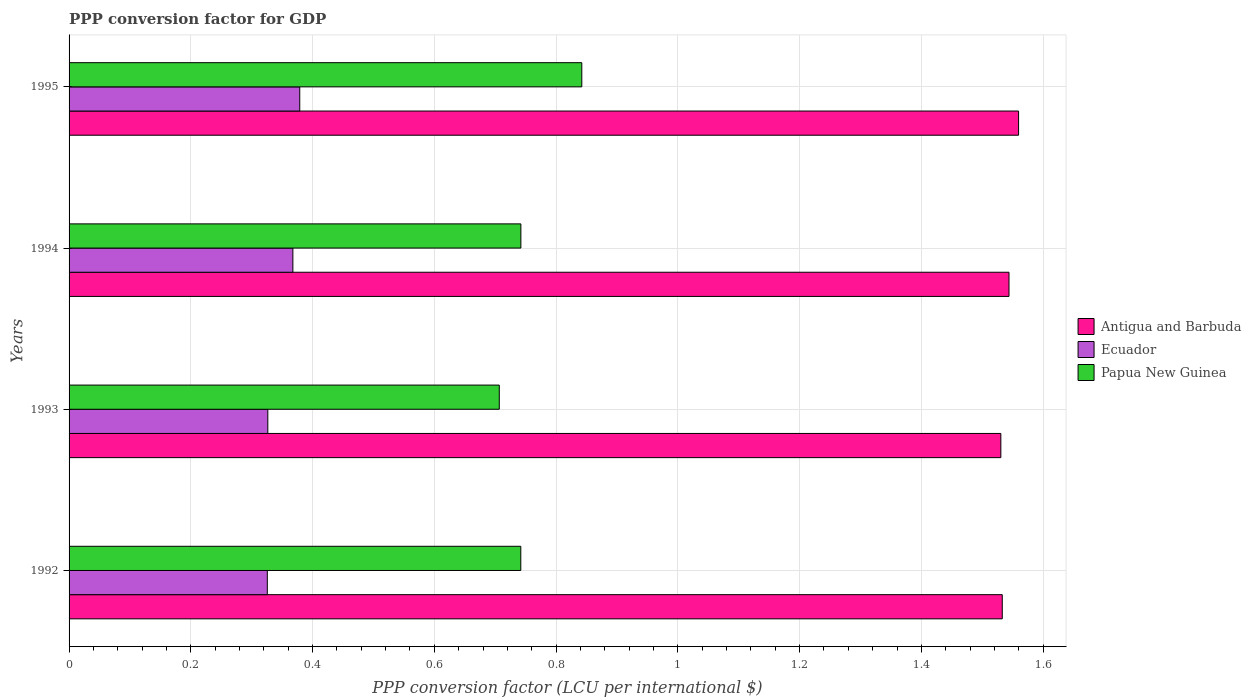Are the number of bars per tick equal to the number of legend labels?
Offer a terse response. Yes. How many bars are there on the 3rd tick from the top?
Keep it short and to the point. 3. What is the label of the 2nd group of bars from the top?
Provide a short and direct response. 1994. In how many cases, is the number of bars for a given year not equal to the number of legend labels?
Your answer should be very brief. 0. What is the PPP conversion factor for GDP in Papua New Guinea in 1994?
Offer a very short reply. 0.74. Across all years, what is the maximum PPP conversion factor for GDP in Ecuador?
Make the answer very short. 0.38. Across all years, what is the minimum PPP conversion factor for GDP in Ecuador?
Offer a very short reply. 0.33. In which year was the PPP conversion factor for GDP in Ecuador minimum?
Your answer should be compact. 1992. What is the total PPP conversion factor for GDP in Papua New Guinea in the graph?
Offer a very short reply. 3.03. What is the difference between the PPP conversion factor for GDP in Ecuador in 1992 and that in 1993?
Offer a very short reply. -0. What is the difference between the PPP conversion factor for GDP in Ecuador in 1993 and the PPP conversion factor for GDP in Papua New Guinea in 1992?
Your answer should be compact. -0.42. What is the average PPP conversion factor for GDP in Ecuador per year?
Offer a very short reply. 0.35. In the year 1994, what is the difference between the PPP conversion factor for GDP in Antigua and Barbuda and PPP conversion factor for GDP in Papua New Guinea?
Your answer should be very brief. 0.8. What is the ratio of the PPP conversion factor for GDP in Ecuador in 1992 to that in 1994?
Your answer should be very brief. 0.89. What is the difference between the highest and the second highest PPP conversion factor for GDP in Antigua and Barbuda?
Your response must be concise. 0.02. What is the difference between the highest and the lowest PPP conversion factor for GDP in Antigua and Barbuda?
Offer a very short reply. 0.03. In how many years, is the PPP conversion factor for GDP in Antigua and Barbuda greater than the average PPP conversion factor for GDP in Antigua and Barbuda taken over all years?
Your answer should be compact. 2. What does the 3rd bar from the top in 1995 represents?
Your answer should be compact. Antigua and Barbuda. What does the 2nd bar from the bottom in 1994 represents?
Provide a succinct answer. Ecuador. How many bars are there?
Your answer should be compact. 12. How many years are there in the graph?
Your answer should be very brief. 4. Are the values on the major ticks of X-axis written in scientific E-notation?
Provide a short and direct response. No. Where does the legend appear in the graph?
Offer a very short reply. Center right. How are the legend labels stacked?
Provide a short and direct response. Vertical. What is the title of the graph?
Your response must be concise. PPP conversion factor for GDP. Does "Portugal" appear as one of the legend labels in the graph?
Offer a very short reply. No. What is the label or title of the X-axis?
Your answer should be compact. PPP conversion factor (LCU per international $). What is the label or title of the Y-axis?
Ensure brevity in your answer.  Years. What is the PPP conversion factor (LCU per international $) in Antigua and Barbuda in 1992?
Your response must be concise. 1.53. What is the PPP conversion factor (LCU per international $) of Ecuador in 1992?
Ensure brevity in your answer.  0.33. What is the PPP conversion factor (LCU per international $) in Papua New Guinea in 1992?
Make the answer very short. 0.74. What is the PPP conversion factor (LCU per international $) of Antigua and Barbuda in 1993?
Your response must be concise. 1.53. What is the PPP conversion factor (LCU per international $) in Ecuador in 1993?
Your response must be concise. 0.33. What is the PPP conversion factor (LCU per international $) of Papua New Guinea in 1993?
Provide a short and direct response. 0.71. What is the PPP conversion factor (LCU per international $) in Antigua and Barbuda in 1994?
Keep it short and to the point. 1.54. What is the PPP conversion factor (LCU per international $) of Ecuador in 1994?
Ensure brevity in your answer.  0.37. What is the PPP conversion factor (LCU per international $) of Papua New Guinea in 1994?
Your answer should be compact. 0.74. What is the PPP conversion factor (LCU per international $) in Antigua and Barbuda in 1995?
Offer a terse response. 1.56. What is the PPP conversion factor (LCU per international $) of Ecuador in 1995?
Offer a very short reply. 0.38. What is the PPP conversion factor (LCU per international $) of Papua New Guinea in 1995?
Make the answer very short. 0.84. Across all years, what is the maximum PPP conversion factor (LCU per international $) in Antigua and Barbuda?
Offer a terse response. 1.56. Across all years, what is the maximum PPP conversion factor (LCU per international $) of Ecuador?
Provide a short and direct response. 0.38. Across all years, what is the maximum PPP conversion factor (LCU per international $) in Papua New Guinea?
Keep it short and to the point. 0.84. Across all years, what is the minimum PPP conversion factor (LCU per international $) in Antigua and Barbuda?
Your answer should be compact. 1.53. Across all years, what is the minimum PPP conversion factor (LCU per international $) of Ecuador?
Your answer should be very brief. 0.33. Across all years, what is the minimum PPP conversion factor (LCU per international $) of Papua New Guinea?
Give a very brief answer. 0.71. What is the total PPP conversion factor (LCU per international $) of Antigua and Barbuda in the graph?
Offer a terse response. 6.17. What is the total PPP conversion factor (LCU per international $) in Ecuador in the graph?
Keep it short and to the point. 1.4. What is the total PPP conversion factor (LCU per international $) of Papua New Guinea in the graph?
Ensure brevity in your answer.  3.03. What is the difference between the PPP conversion factor (LCU per international $) in Antigua and Barbuda in 1992 and that in 1993?
Offer a terse response. 0. What is the difference between the PPP conversion factor (LCU per international $) in Ecuador in 1992 and that in 1993?
Offer a terse response. -0. What is the difference between the PPP conversion factor (LCU per international $) of Papua New Guinea in 1992 and that in 1993?
Provide a short and direct response. 0.04. What is the difference between the PPP conversion factor (LCU per international $) of Antigua and Barbuda in 1992 and that in 1994?
Your answer should be compact. -0.01. What is the difference between the PPP conversion factor (LCU per international $) of Ecuador in 1992 and that in 1994?
Ensure brevity in your answer.  -0.04. What is the difference between the PPP conversion factor (LCU per international $) of Papua New Guinea in 1992 and that in 1994?
Provide a succinct answer. -0. What is the difference between the PPP conversion factor (LCU per international $) in Antigua and Barbuda in 1992 and that in 1995?
Offer a very short reply. -0.03. What is the difference between the PPP conversion factor (LCU per international $) of Ecuador in 1992 and that in 1995?
Offer a very short reply. -0.05. What is the difference between the PPP conversion factor (LCU per international $) of Papua New Guinea in 1992 and that in 1995?
Offer a terse response. -0.1. What is the difference between the PPP conversion factor (LCU per international $) in Antigua and Barbuda in 1993 and that in 1994?
Your answer should be very brief. -0.01. What is the difference between the PPP conversion factor (LCU per international $) in Ecuador in 1993 and that in 1994?
Your answer should be very brief. -0.04. What is the difference between the PPP conversion factor (LCU per international $) of Papua New Guinea in 1993 and that in 1994?
Your answer should be very brief. -0.04. What is the difference between the PPP conversion factor (LCU per international $) in Antigua and Barbuda in 1993 and that in 1995?
Keep it short and to the point. -0.03. What is the difference between the PPP conversion factor (LCU per international $) in Ecuador in 1993 and that in 1995?
Make the answer very short. -0.05. What is the difference between the PPP conversion factor (LCU per international $) in Papua New Guinea in 1993 and that in 1995?
Keep it short and to the point. -0.14. What is the difference between the PPP conversion factor (LCU per international $) in Antigua and Barbuda in 1994 and that in 1995?
Provide a succinct answer. -0.02. What is the difference between the PPP conversion factor (LCU per international $) of Ecuador in 1994 and that in 1995?
Your answer should be compact. -0.01. What is the difference between the PPP conversion factor (LCU per international $) of Papua New Guinea in 1994 and that in 1995?
Offer a terse response. -0.1. What is the difference between the PPP conversion factor (LCU per international $) of Antigua and Barbuda in 1992 and the PPP conversion factor (LCU per international $) of Ecuador in 1993?
Ensure brevity in your answer.  1.21. What is the difference between the PPP conversion factor (LCU per international $) of Antigua and Barbuda in 1992 and the PPP conversion factor (LCU per international $) of Papua New Guinea in 1993?
Give a very brief answer. 0.83. What is the difference between the PPP conversion factor (LCU per international $) in Ecuador in 1992 and the PPP conversion factor (LCU per international $) in Papua New Guinea in 1993?
Keep it short and to the point. -0.38. What is the difference between the PPP conversion factor (LCU per international $) of Antigua and Barbuda in 1992 and the PPP conversion factor (LCU per international $) of Ecuador in 1994?
Offer a terse response. 1.17. What is the difference between the PPP conversion factor (LCU per international $) of Antigua and Barbuda in 1992 and the PPP conversion factor (LCU per international $) of Papua New Guinea in 1994?
Your answer should be compact. 0.79. What is the difference between the PPP conversion factor (LCU per international $) in Ecuador in 1992 and the PPP conversion factor (LCU per international $) in Papua New Guinea in 1994?
Your answer should be very brief. -0.42. What is the difference between the PPP conversion factor (LCU per international $) in Antigua and Barbuda in 1992 and the PPP conversion factor (LCU per international $) in Ecuador in 1995?
Offer a terse response. 1.15. What is the difference between the PPP conversion factor (LCU per international $) of Antigua and Barbuda in 1992 and the PPP conversion factor (LCU per international $) of Papua New Guinea in 1995?
Ensure brevity in your answer.  0.69. What is the difference between the PPP conversion factor (LCU per international $) of Ecuador in 1992 and the PPP conversion factor (LCU per international $) of Papua New Guinea in 1995?
Your answer should be compact. -0.52. What is the difference between the PPP conversion factor (LCU per international $) of Antigua and Barbuda in 1993 and the PPP conversion factor (LCU per international $) of Ecuador in 1994?
Offer a very short reply. 1.16. What is the difference between the PPP conversion factor (LCU per international $) in Antigua and Barbuda in 1993 and the PPP conversion factor (LCU per international $) in Papua New Guinea in 1994?
Your answer should be very brief. 0.79. What is the difference between the PPP conversion factor (LCU per international $) in Ecuador in 1993 and the PPP conversion factor (LCU per international $) in Papua New Guinea in 1994?
Your answer should be compact. -0.42. What is the difference between the PPP conversion factor (LCU per international $) in Antigua and Barbuda in 1993 and the PPP conversion factor (LCU per international $) in Ecuador in 1995?
Provide a succinct answer. 1.15. What is the difference between the PPP conversion factor (LCU per international $) of Antigua and Barbuda in 1993 and the PPP conversion factor (LCU per international $) of Papua New Guinea in 1995?
Make the answer very short. 0.69. What is the difference between the PPP conversion factor (LCU per international $) in Ecuador in 1993 and the PPP conversion factor (LCU per international $) in Papua New Guinea in 1995?
Offer a terse response. -0.52. What is the difference between the PPP conversion factor (LCU per international $) of Antigua and Barbuda in 1994 and the PPP conversion factor (LCU per international $) of Ecuador in 1995?
Provide a succinct answer. 1.17. What is the difference between the PPP conversion factor (LCU per international $) of Antigua and Barbuda in 1994 and the PPP conversion factor (LCU per international $) of Papua New Guinea in 1995?
Make the answer very short. 0.7. What is the difference between the PPP conversion factor (LCU per international $) in Ecuador in 1994 and the PPP conversion factor (LCU per international $) in Papua New Guinea in 1995?
Offer a very short reply. -0.47. What is the average PPP conversion factor (LCU per international $) of Antigua and Barbuda per year?
Ensure brevity in your answer.  1.54. What is the average PPP conversion factor (LCU per international $) of Ecuador per year?
Your response must be concise. 0.35. What is the average PPP conversion factor (LCU per international $) of Papua New Guinea per year?
Offer a very short reply. 0.76. In the year 1992, what is the difference between the PPP conversion factor (LCU per international $) of Antigua and Barbuda and PPP conversion factor (LCU per international $) of Ecuador?
Your answer should be compact. 1.21. In the year 1992, what is the difference between the PPP conversion factor (LCU per international $) of Antigua and Barbuda and PPP conversion factor (LCU per international $) of Papua New Guinea?
Make the answer very short. 0.79. In the year 1992, what is the difference between the PPP conversion factor (LCU per international $) of Ecuador and PPP conversion factor (LCU per international $) of Papua New Guinea?
Ensure brevity in your answer.  -0.42. In the year 1993, what is the difference between the PPP conversion factor (LCU per international $) in Antigua and Barbuda and PPP conversion factor (LCU per international $) in Ecuador?
Provide a succinct answer. 1.2. In the year 1993, what is the difference between the PPP conversion factor (LCU per international $) in Antigua and Barbuda and PPP conversion factor (LCU per international $) in Papua New Guinea?
Offer a terse response. 0.82. In the year 1993, what is the difference between the PPP conversion factor (LCU per international $) of Ecuador and PPP conversion factor (LCU per international $) of Papua New Guinea?
Your answer should be compact. -0.38. In the year 1994, what is the difference between the PPP conversion factor (LCU per international $) in Antigua and Barbuda and PPP conversion factor (LCU per international $) in Ecuador?
Your answer should be very brief. 1.18. In the year 1994, what is the difference between the PPP conversion factor (LCU per international $) of Antigua and Barbuda and PPP conversion factor (LCU per international $) of Papua New Guinea?
Your answer should be very brief. 0.8. In the year 1994, what is the difference between the PPP conversion factor (LCU per international $) in Ecuador and PPP conversion factor (LCU per international $) in Papua New Guinea?
Provide a short and direct response. -0.37. In the year 1995, what is the difference between the PPP conversion factor (LCU per international $) of Antigua and Barbuda and PPP conversion factor (LCU per international $) of Ecuador?
Provide a short and direct response. 1.18. In the year 1995, what is the difference between the PPP conversion factor (LCU per international $) in Antigua and Barbuda and PPP conversion factor (LCU per international $) in Papua New Guinea?
Ensure brevity in your answer.  0.72. In the year 1995, what is the difference between the PPP conversion factor (LCU per international $) of Ecuador and PPP conversion factor (LCU per international $) of Papua New Guinea?
Give a very brief answer. -0.46. What is the ratio of the PPP conversion factor (LCU per international $) of Antigua and Barbuda in 1992 to that in 1993?
Offer a very short reply. 1. What is the ratio of the PPP conversion factor (LCU per international $) of Ecuador in 1992 to that in 1993?
Ensure brevity in your answer.  1. What is the ratio of the PPP conversion factor (LCU per international $) of Papua New Guinea in 1992 to that in 1993?
Keep it short and to the point. 1.05. What is the ratio of the PPP conversion factor (LCU per international $) in Ecuador in 1992 to that in 1994?
Give a very brief answer. 0.89. What is the ratio of the PPP conversion factor (LCU per international $) in Antigua and Barbuda in 1992 to that in 1995?
Ensure brevity in your answer.  0.98. What is the ratio of the PPP conversion factor (LCU per international $) of Ecuador in 1992 to that in 1995?
Offer a terse response. 0.86. What is the ratio of the PPP conversion factor (LCU per international $) in Papua New Guinea in 1992 to that in 1995?
Provide a succinct answer. 0.88. What is the ratio of the PPP conversion factor (LCU per international $) of Antigua and Barbuda in 1993 to that in 1994?
Make the answer very short. 0.99. What is the ratio of the PPP conversion factor (LCU per international $) of Ecuador in 1993 to that in 1994?
Keep it short and to the point. 0.89. What is the ratio of the PPP conversion factor (LCU per international $) of Papua New Guinea in 1993 to that in 1994?
Ensure brevity in your answer.  0.95. What is the ratio of the PPP conversion factor (LCU per international $) in Antigua and Barbuda in 1993 to that in 1995?
Your answer should be compact. 0.98. What is the ratio of the PPP conversion factor (LCU per international $) in Ecuador in 1993 to that in 1995?
Your answer should be very brief. 0.86. What is the ratio of the PPP conversion factor (LCU per international $) in Papua New Guinea in 1993 to that in 1995?
Provide a succinct answer. 0.84. What is the ratio of the PPP conversion factor (LCU per international $) of Ecuador in 1994 to that in 1995?
Your response must be concise. 0.97. What is the ratio of the PPP conversion factor (LCU per international $) of Papua New Guinea in 1994 to that in 1995?
Your answer should be very brief. 0.88. What is the difference between the highest and the second highest PPP conversion factor (LCU per international $) in Antigua and Barbuda?
Offer a terse response. 0.02. What is the difference between the highest and the second highest PPP conversion factor (LCU per international $) in Ecuador?
Ensure brevity in your answer.  0.01. What is the difference between the highest and the second highest PPP conversion factor (LCU per international $) in Papua New Guinea?
Offer a terse response. 0.1. What is the difference between the highest and the lowest PPP conversion factor (LCU per international $) of Antigua and Barbuda?
Provide a short and direct response. 0.03. What is the difference between the highest and the lowest PPP conversion factor (LCU per international $) of Ecuador?
Provide a succinct answer. 0.05. What is the difference between the highest and the lowest PPP conversion factor (LCU per international $) of Papua New Guinea?
Keep it short and to the point. 0.14. 